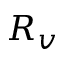<formula> <loc_0><loc_0><loc_500><loc_500>R _ { v }</formula> 